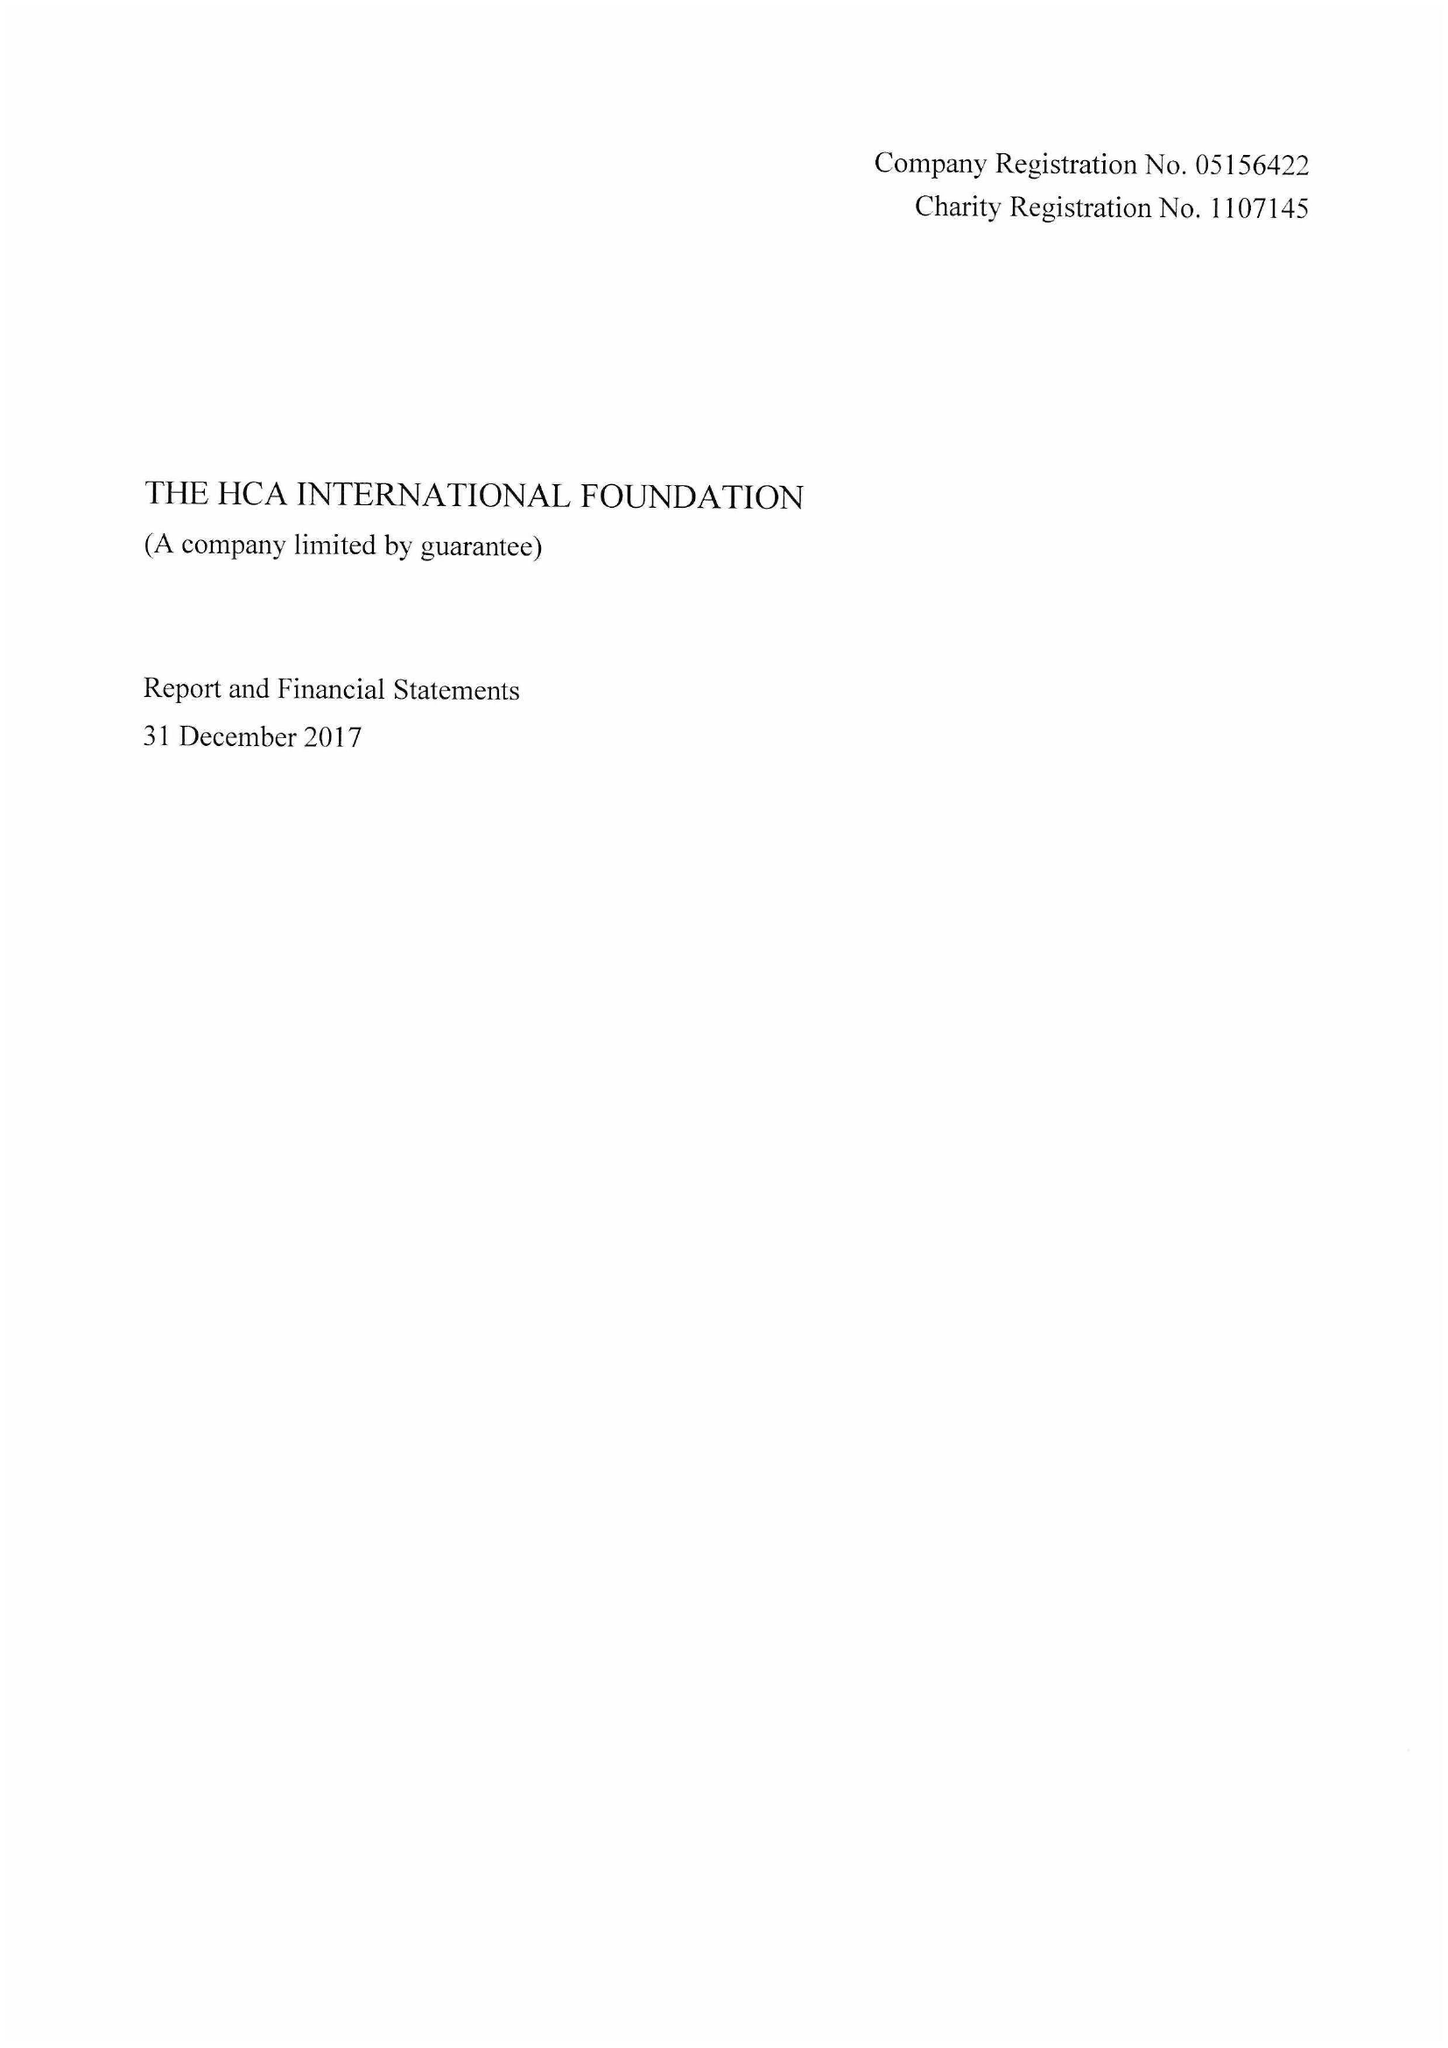What is the value for the charity_name?
Answer the question using a single word or phrase. The Hca International Foundation 